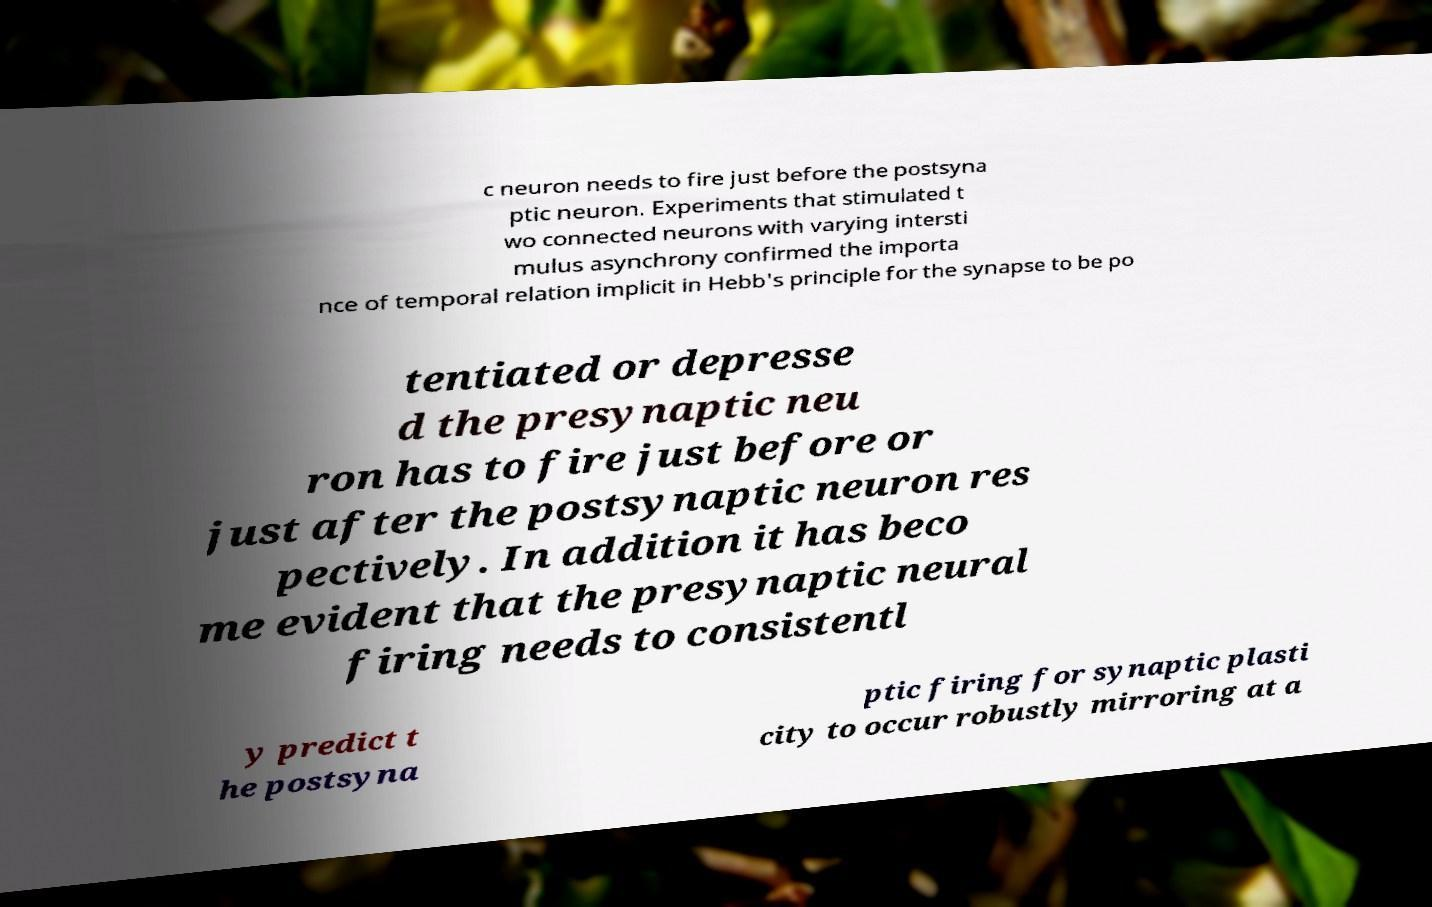Please identify and transcribe the text found in this image. c neuron needs to fire just before the postsyna ptic neuron. Experiments that stimulated t wo connected neurons with varying intersti mulus asynchrony confirmed the importa nce of temporal relation implicit in Hebb's principle for the synapse to be po tentiated or depresse d the presynaptic neu ron has to fire just before or just after the postsynaptic neuron res pectively. In addition it has beco me evident that the presynaptic neural firing needs to consistentl y predict t he postsyna ptic firing for synaptic plasti city to occur robustly mirroring at a 